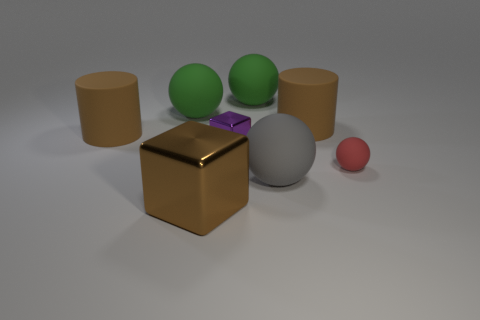Add 2 gray matte things. How many objects exist? 10 Subtract all small red spheres. How many spheres are left? 3 Subtract all cyan cubes. How many green spheres are left? 2 Subtract all red balls. How many balls are left? 3 Subtract 2 balls. How many balls are left? 2 Subtract all cylinders. How many objects are left? 6 Subtract all cyan spheres. Subtract all green blocks. How many spheres are left? 4 Subtract all brown things. Subtract all gray rubber cylinders. How many objects are left? 5 Add 7 purple things. How many purple things are left? 8 Add 8 large blocks. How many large blocks exist? 9 